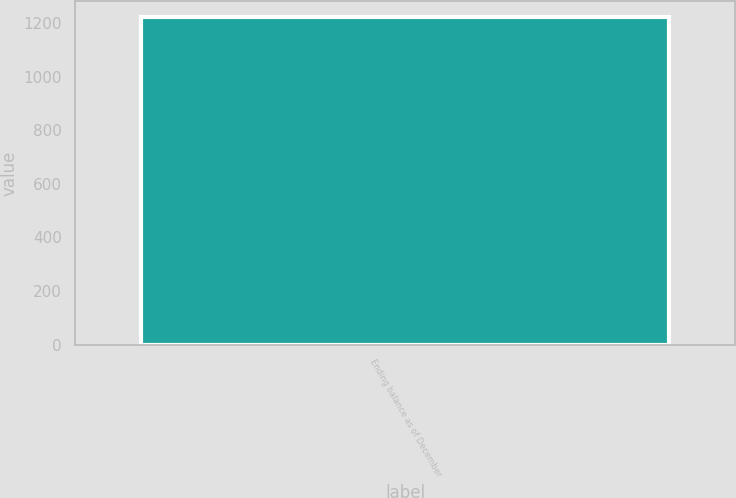<chart> <loc_0><loc_0><loc_500><loc_500><bar_chart><fcel>Ending balance as of December<nl><fcel>1221<nl></chart> 